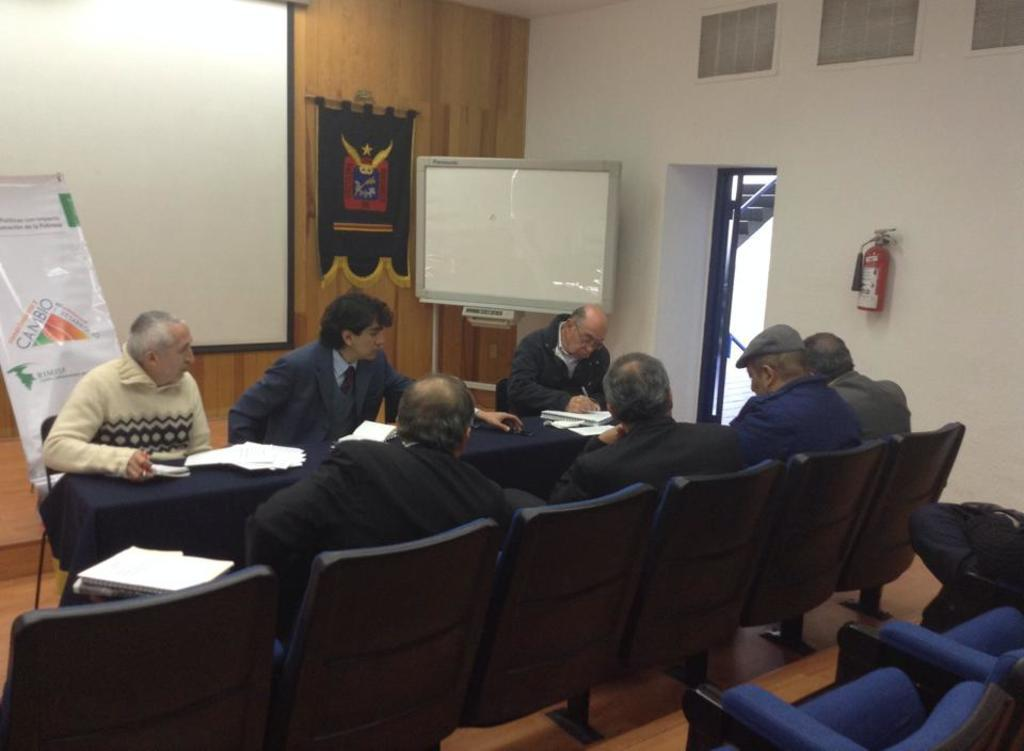How many people are in the image? There is a group of people in the image. What are the people doing in the image? The people are sitting in chairs. What is in front of the people? There is a table in front of the people. What is on the table? The table has a book and papers on it. What other objects can be seen in the image? There is a board and a projector in the image. What type of meal is being served in the image? There is no meal present in the image; it features a group of people sitting at a table with a book, papers, a board, and a projector. 